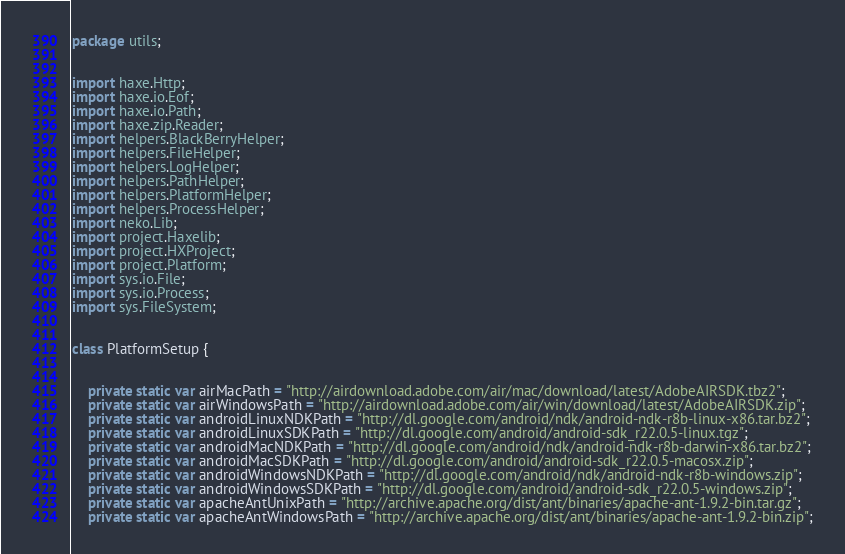<code> <loc_0><loc_0><loc_500><loc_500><_Haxe_>package utils;


import haxe.Http;
import haxe.io.Eof;
import haxe.io.Path;
import haxe.zip.Reader;
import helpers.BlackBerryHelper;
import helpers.FileHelper;
import helpers.LogHelper;
import helpers.PathHelper;
import helpers.PlatformHelper;
import helpers.ProcessHelper;
import neko.Lib;
import project.Haxelib;
import project.HXProject;
import project.Platform;
import sys.io.File;
import sys.io.Process;
import sys.FileSystem;


class PlatformSetup {
	
	
	private static var airMacPath = "http://airdownload.adobe.com/air/mac/download/latest/AdobeAIRSDK.tbz2";
	private static var airWindowsPath = "http://airdownload.adobe.com/air/win/download/latest/AdobeAIRSDK.zip";
	private static var androidLinuxNDKPath = "http://dl.google.com/android/ndk/android-ndk-r8b-linux-x86.tar.bz2";
	private static var androidLinuxSDKPath = "http://dl.google.com/android/android-sdk_r22.0.5-linux.tgz";
	private static var androidMacNDKPath = "http://dl.google.com/android/ndk/android-ndk-r8b-darwin-x86.tar.bz2";
	private static var androidMacSDKPath = "http://dl.google.com/android/android-sdk_r22.0.5-macosx.zip";
	private static var androidWindowsNDKPath = "http://dl.google.com/android/ndk/android-ndk-r8b-windows.zip";
	private static var androidWindowsSDKPath = "http://dl.google.com/android/android-sdk_r22.0.5-windows.zip";
	private static var apacheAntUnixPath = "http://archive.apache.org/dist/ant/binaries/apache-ant-1.9.2-bin.tar.gz";
	private static var apacheAntWindowsPath = "http://archive.apache.org/dist/ant/binaries/apache-ant-1.9.2-bin.zip";</code> 